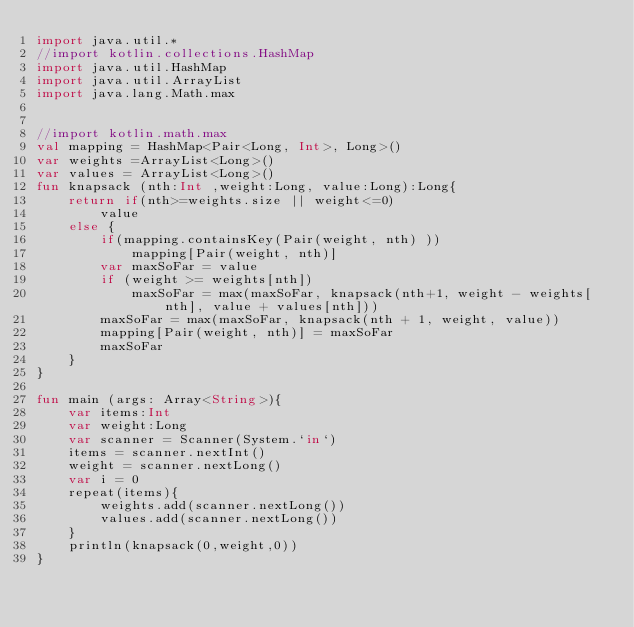Convert code to text. <code><loc_0><loc_0><loc_500><loc_500><_Kotlin_>import java.util.*
//import kotlin.collections.HashMap
import java.util.HashMap
import java.util.ArrayList
import java.lang.Math.max


//import kotlin.math.max
val mapping = HashMap<Pair<Long, Int>, Long>()
var weights =ArrayList<Long>()
var values = ArrayList<Long>()
fun knapsack (nth:Int ,weight:Long, value:Long):Long{
    return if(nth>=weights.size || weight<=0)
        value
    else {
        if(mapping.containsKey(Pair(weight, nth) ))
            mapping[Pair(weight, nth)]
        var maxSoFar = value
        if (weight >= weights[nth])
            maxSoFar = max(maxSoFar, knapsack(nth+1, weight - weights[nth], value + values[nth]))
        maxSoFar = max(maxSoFar, knapsack(nth + 1, weight, value))
        mapping[Pair(weight, nth)] = maxSoFar
        maxSoFar
    }
}

fun main (args: Array<String>){
    var items:Int
    var weight:Long
    var scanner = Scanner(System.`in`)
    items = scanner.nextInt()
    weight = scanner.nextLong()
    var i = 0
    repeat(items){
        weights.add(scanner.nextLong())
        values.add(scanner.nextLong())
    }
    println(knapsack(0,weight,0))
}</code> 